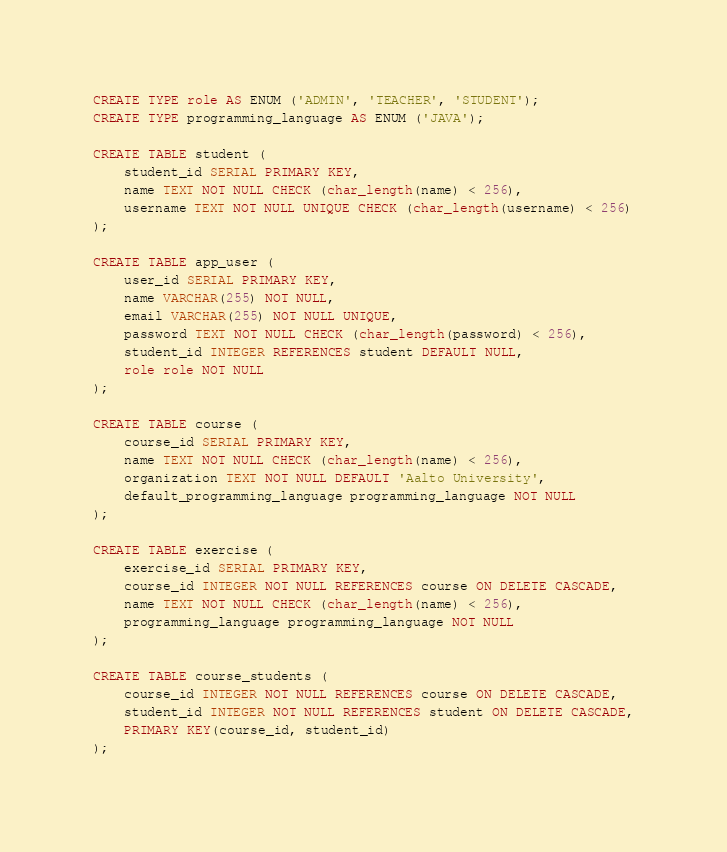Convert code to text. <code><loc_0><loc_0><loc_500><loc_500><_SQL_>CREATE TYPE role AS ENUM ('ADMIN', 'TEACHER', 'STUDENT');
CREATE TYPE programming_language AS ENUM ('JAVA');

CREATE TABLE student (
	student_id SERIAL PRIMARY KEY,
	name TEXT NOT NULL CHECK (char_length(name) < 256),
	username TEXT NOT NULL UNIQUE CHECK (char_length(username) < 256)
);

CREATE TABLE app_user (
	user_id SERIAL PRIMARY KEY,
	name VARCHAR(255) NOT NULL,
	email VARCHAR(255) NOT NULL UNIQUE,
	password TEXT NOT NULL CHECK (char_length(password) < 256),
	student_id INTEGER REFERENCES student DEFAULT NULL,
	role role NOT NULL
);

CREATE TABLE course (
	course_id SERIAL PRIMARY KEY,
	name TEXT NOT NULL CHECK (char_length(name) < 256),
	organization TEXT NOT NULL DEFAULT 'Aalto University',
	default_programming_language programming_language NOT NULL
);

CREATE TABLE exercise (
	exercise_id SERIAL PRIMARY KEY,
	course_id INTEGER NOT NULL REFERENCES course ON DELETE CASCADE,
	name TEXT NOT NULL CHECK (char_length(name) < 256),
	programming_language programming_language NOT NULL
);

CREATE TABLE course_students (
	course_id INTEGER NOT NULL REFERENCES course ON DELETE CASCADE,
	student_id INTEGER NOT NULL REFERENCES student ON DELETE CASCADE,
	PRIMARY KEY(course_id, student_id)
);
</code> 